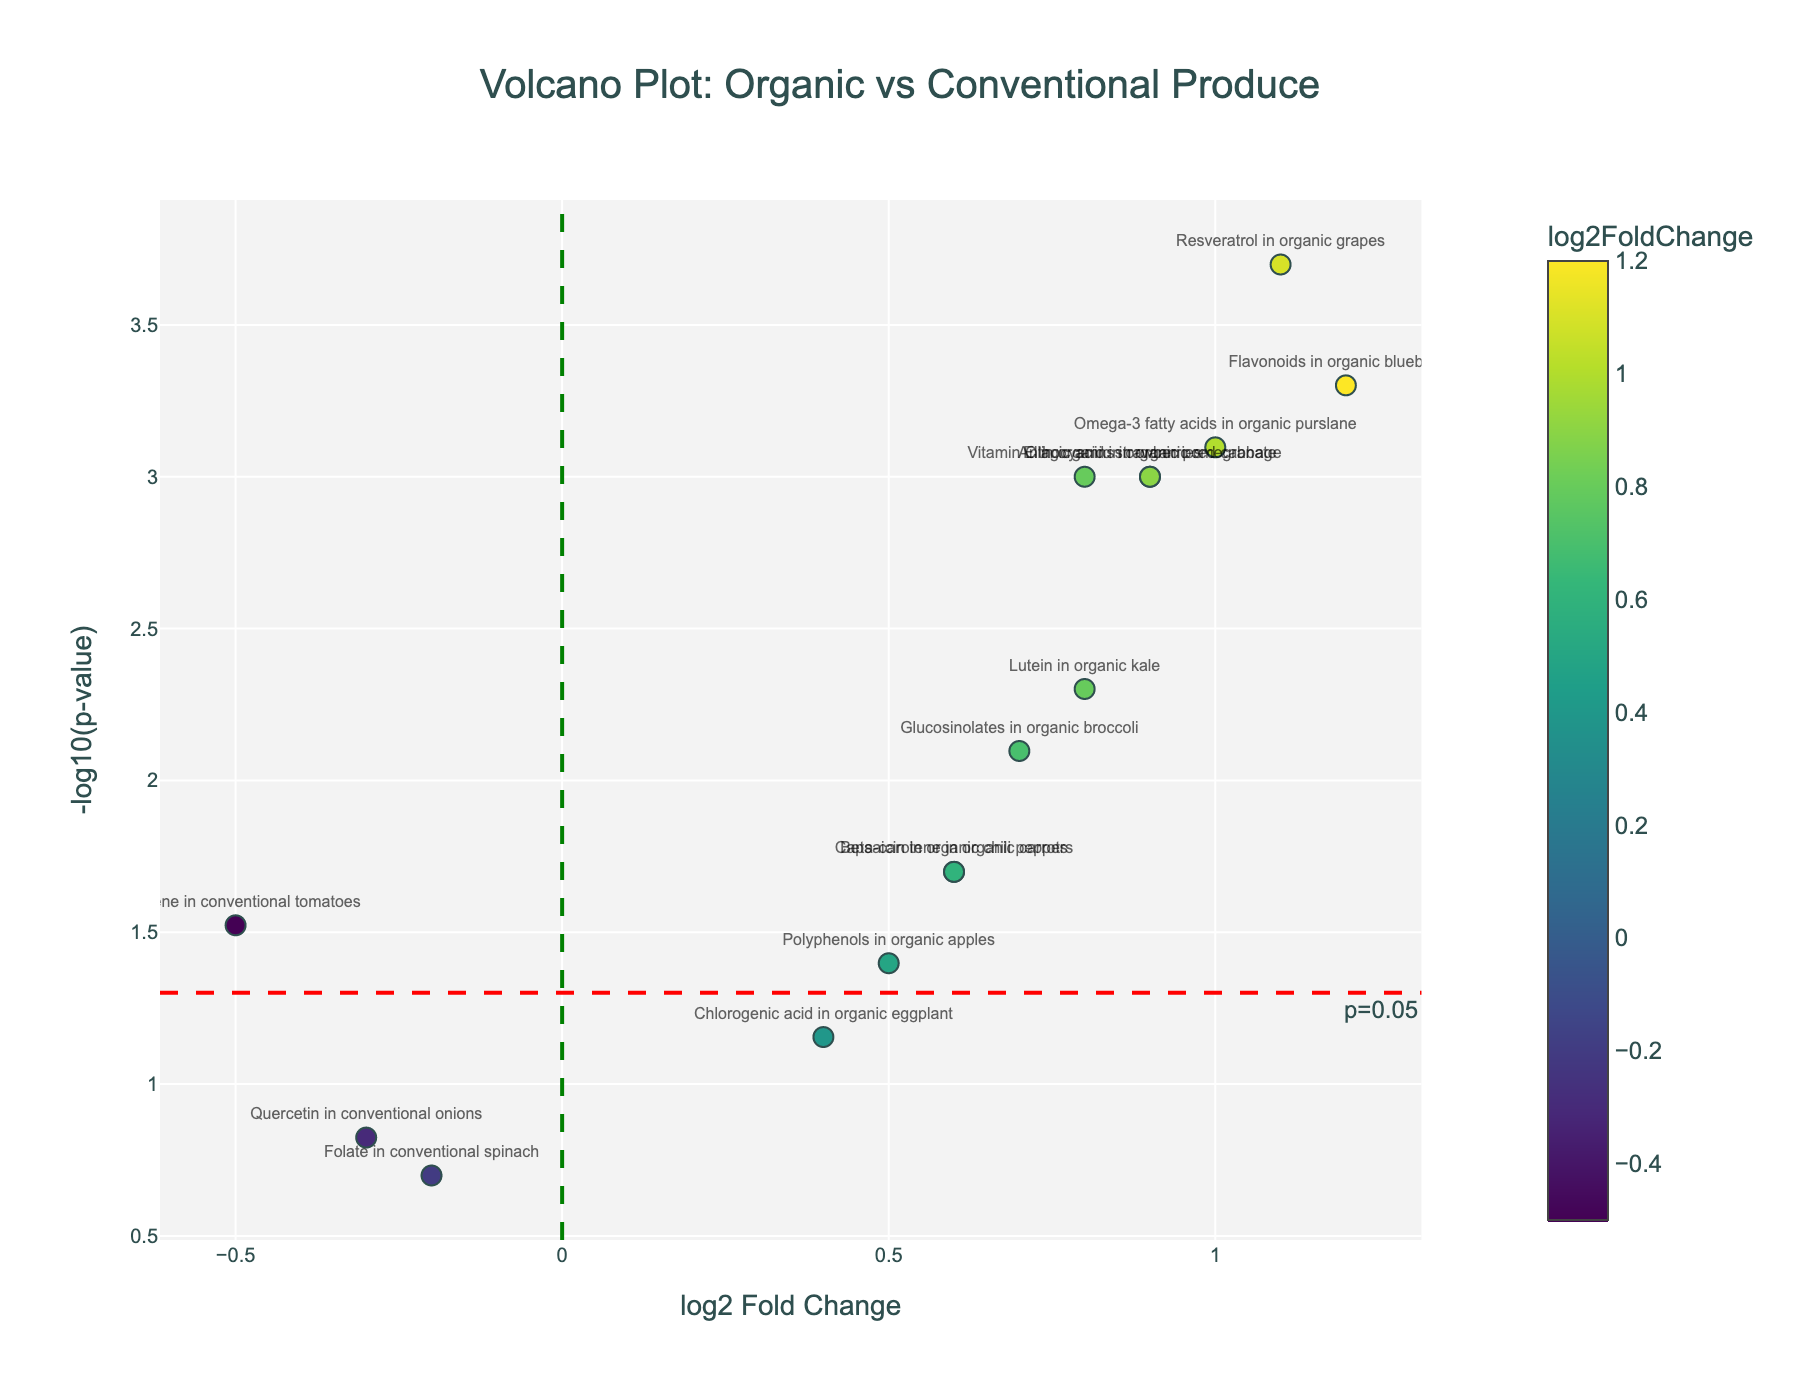How many data points are above the significance line (p=0.05)? The significance line is at -log10(p-value) = 1.3. Count the points with -log10(p-value) > 1.3.
Answer: 9 Which nutrient has the highest log2 Fold Change in organic produce? Look for the highest log2 Fold Change value among items labeled as 'organic'.
Answer: Flavonoids in organic blueberries What is the log2 Fold Change for Lycopene in conventional tomatoes? Find the data point labeled 'Lycopene in conventional tomatoes' on the x-axis (log2 Fold Change).
Answer: -0.5 Which compounds have a significant increase in organic produce (log2 Fold Change > 0 and p < 0.05)? Find compounds with log2 Fold Change > 0 and -log10(p-value) > 1.3, indicating significant p-values.
Answer: Vitamin C in organic strawberries, Flavonoids in organic blueberries, Beta-carotene in organic carrots, Anthocyanins in organic red cabbage, Glucosinolates in organic broccoli, Resveratrol in organic grapes, Lutein in organic kale, Omega-3 fatty acids in organic purslane, Capsaicin in organic chili peppers, and Ellagic acid in organic pomegranate Are any nutrients in conventional produce significantly better than in organic produce? Look for nutrients in conventional produce with -log10(p-value) > 1.3 and a positive log2 Fold Change.
Answer: None What is the p-value for Omega-3 fatty acids in organic purslane? Identify the data point for 'Omega-3 fatty acids in organic purslane' and trace its y-axis value back to its corresponding p-value using the -log10 transformation.
Answer: 0.0008 How does the log2 Fold Change for Anthocyanins in organic red cabbage compare to Polyphenols in organic apples? Compare the log2 Fold Change values for both compounds.
Answer: 0.9 vs 0.5 Are there any data points near the vertical reference line at log2 Fold Change = 0? Look for data points close to log2 Fold Change = 0, indicating similar levels in organic and conventional produce.
Answer: Chlorogenic acid in organic eggplant and Folate in conventional spinach Which compound is farthest to the right on the plot? Identify the point with the highest positive log2 Fold Change value.
Answer: Flavonoids in organic blueberries 